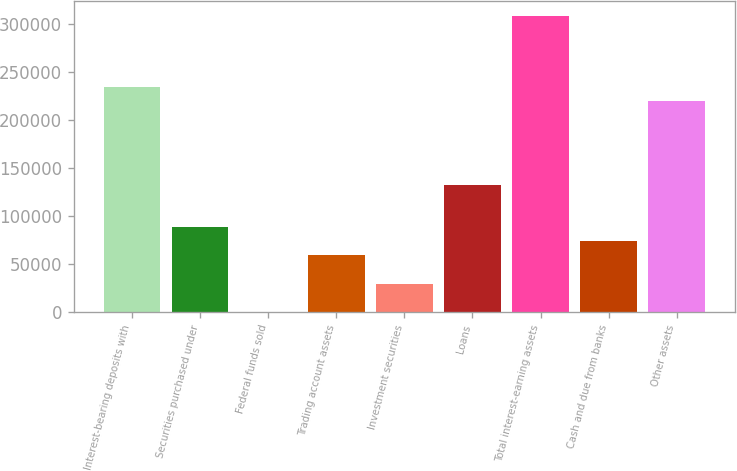Convert chart. <chart><loc_0><loc_0><loc_500><loc_500><bar_chart><fcel>Interest-bearing deposits with<fcel>Securities purchased under<fcel>Federal funds sold<fcel>Trading account assets<fcel>Investment securities<fcel>Loans<fcel>Total interest-earning assets<fcel>Cash and due from banks<fcel>Other assets<nl><fcel>234855<fcel>88113.2<fcel>68<fcel>58764.8<fcel>29416.4<fcel>132136<fcel>308226<fcel>73439<fcel>220181<nl></chart> 